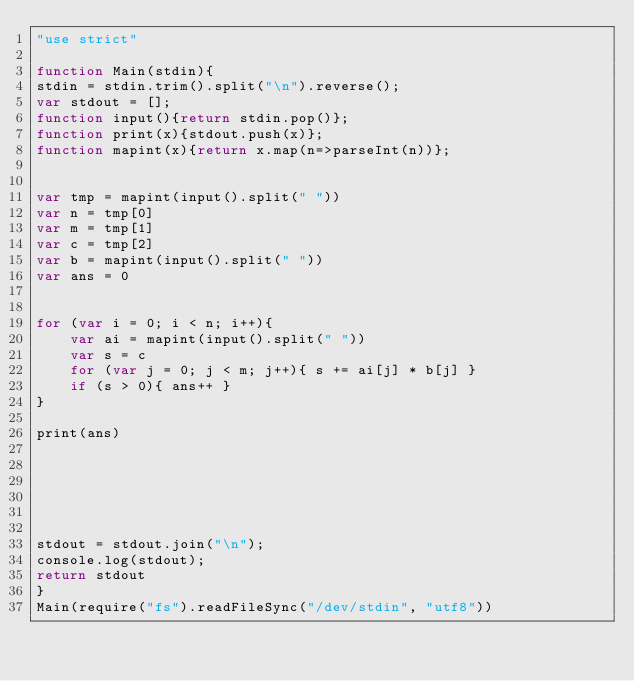Convert code to text. <code><loc_0><loc_0><loc_500><loc_500><_JavaScript_>"use strict"

function Main(stdin){
stdin = stdin.trim().split("\n").reverse();
var stdout = [];
function input(){return stdin.pop()};
function print(x){stdout.push(x)};
function mapint(x){return x.map(n=>parseInt(n))};


var tmp = mapint(input().split(" "))
var n = tmp[0]
var m = tmp[1]
var c = tmp[2]
var b = mapint(input().split(" "))
var ans = 0


for (var i = 0; i < n; i++){
    var ai = mapint(input().split(" "))
    var s = c
    for (var j = 0; j < m; j++){ s += ai[j] * b[j] }
    if (s > 0){ ans++ }
}

print(ans)






stdout = stdout.join("\n");
console.log(stdout);
return stdout
}
Main(require("fs").readFileSync("/dev/stdin", "utf8"))</code> 